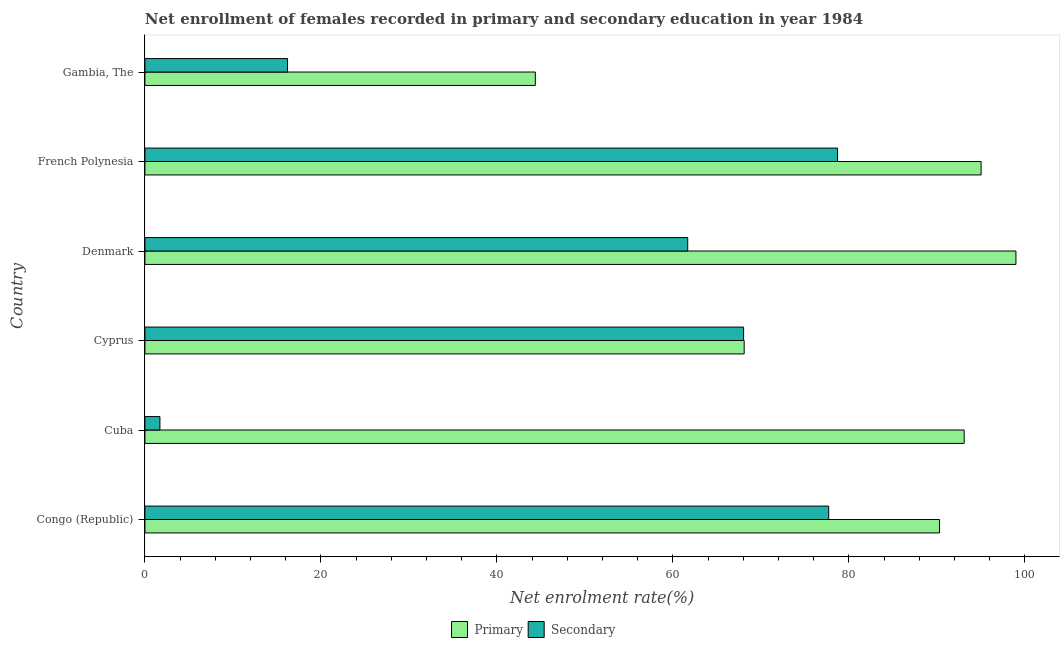How many different coloured bars are there?
Provide a succinct answer. 2. How many groups of bars are there?
Keep it short and to the point. 6. How many bars are there on the 6th tick from the bottom?
Your response must be concise. 2. What is the label of the 3rd group of bars from the top?
Keep it short and to the point. Denmark. In how many cases, is the number of bars for a given country not equal to the number of legend labels?
Provide a succinct answer. 0. What is the enrollment rate in primary education in Denmark?
Give a very brief answer. 98.98. Across all countries, what is the maximum enrollment rate in secondary education?
Offer a very short reply. 78.71. Across all countries, what is the minimum enrollment rate in secondary education?
Provide a succinct answer. 1.71. In which country was the enrollment rate in secondary education maximum?
Offer a terse response. French Polynesia. In which country was the enrollment rate in primary education minimum?
Ensure brevity in your answer.  Gambia, The. What is the total enrollment rate in secondary education in the graph?
Offer a very short reply. 304.03. What is the difference between the enrollment rate in secondary education in Congo (Republic) and that in French Polynesia?
Give a very brief answer. -1.01. What is the difference between the enrollment rate in primary education in French Polynesia and the enrollment rate in secondary education in Denmark?
Give a very brief answer. 33.34. What is the average enrollment rate in primary education per country?
Make the answer very short. 81.64. What is the difference between the enrollment rate in primary education and enrollment rate in secondary education in Cuba?
Offer a terse response. 91.39. What is the ratio of the enrollment rate in primary education in Cyprus to that in Gambia, The?
Provide a short and direct response. 1.53. Is the difference between the enrollment rate in secondary education in Cuba and Cyprus greater than the difference between the enrollment rate in primary education in Cuba and Cyprus?
Make the answer very short. No. What is the difference between the highest and the second highest enrollment rate in secondary education?
Your response must be concise. 1.01. What is the difference between the highest and the lowest enrollment rate in primary education?
Your answer should be compact. 54.62. What does the 2nd bar from the top in Cuba represents?
Your answer should be compact. Primary. What does the 2nd bar from the bottom in Cuba represents?
Keep it short and to the point. Secondary. Are all the bars in the graph horizontal?
Provide a short and direct response. Yes. How many countries are there in the graph?
Keep it short and to the point. 6. Are the values on the major ticks of X-axis written in scientific E-notation?
Offer a very short reply. No. Does the graph contain any zero values?
Your answer should be very brief. No. Does the graph contain grids?
Keep it short and to the point. No. What is the title of the graph?
Your answer should be compact. Net enrollment of females recorded in primary and secondary education in year 1984. Does "Under-5(male)" appear as one of the legend labels in the graph?
Keep it short and to the point. No. What is the label or title of the X-axis?
Provide a succinct answer. Net enrolment rate(%). What is the label or title of the Y-axis?
Your response must be concise. Country. What is the Net enrolment rate(%) of Primary in Congo (Republic)?
Offer a very short reply. 90.3. What is the Net enrolment rate(%) of Secondary in Congo (Republic)?
Offer a terse response. 77.7. What is the Net enrolment rate(%) of Primary in Cuba?
Your response must be concise. 93.1. What is the Net enrolment rate(%) in Secondary in Cuba?
Give a very brief answer. 1.71. What is the Net enrolment rate(%) in Primary in Cyprus?
Your response must be concise. 68.1. What is the Net enrolment rate(%) in Secondary in Cyprus?
Your answer should be compact. 68.03. What is the Net enrolment rate(%) in Primary in Denmark?
Give a very brief answer. 98.98. What is the Net enrolment rate(%) in Secondary in Denmark?
Keep it short and to the point. 61.68. What is the Net enrolment rate(%) of Primary in French Polynesia?
Your answer should be very brief. 95.02. What is the Net enrolment rate(%) of Secondary in French Polynesia?
Provide a succinct answer. 78.71. What is the Net enrolment rate(%) of Primary in Gambia, The?
Ensure brevity in your answer.  44.36. What is the Net enrolment rate(%) of Secondary in Gambia, The?
Provide a short and direct response. 16.21. Across all countries, what is the maximum Net enrolment rate(%) of Primary?
Your answer should be compact. 98.98. Across all countries, what is the maximum Net enrolment rate(%) of Secondary?
Make the answer very short. 78.71. Across all countries, what is the minimum Net enrolment rate(%) in Primary?
Your answer should be compact. 44.36. Across all countries, what is the minimum Net enrolment rate(%) in Secondary?
Make the answer very short. 1.71. What is the total Net enrolment rate(%) in Primary in the graph?
Keep it short and to the point. 489.85. What is the total Net enrolment rate(%) of Secondary in the graph?
Offer a terse response. 304.03. What is the difference between the Net enrolment rate(%) in Primary in Congo (Republic) and that in Cuba?
Offer a very short reply. -2.8. What is the difference between the Net enrolment rate(%) of Secondary in Congo (Republic) and that in Cuba?
Your answer should be compact. 76. What is the difference between the Net enrolment rate(%) of Primary in Congo (Republic) and that in Cyprus?
Offer a very short reply. 22.2. What is the difference between the Net enrolment rate(%) in Secondary in Congo (Republic) and that in Cyprus?
Give a very brief answer. 9.67. What is the difference between the Net enrolment rate(%) in Primary in Congo (Republic) and that in Denmark?
Offer a very short reply. -8.68. What is the difference between the Net enrolment rate(%) of Secondary in Congo (Republic) and that in Denmark?
Your response must be concise. 16.02. What is the difference between the Net enrolment rate(%) in Primary in Congo (Republic) and that in French Polynesia?
Your answer should be very brief. -4.72. What is the difference between the Net enrolment rate(%) in Secondary in Congo (Republic) and that in French Polynesia?
Your answer should be compact. -1.01. What is the difference between the Net enrolment rate(%) of Primary in Congo (Republic) and that in Gambia, The?
Offer a very short reply. 45.94. What is the difference between the Net enrolment rate(%) in Secondary in Congo (Republic) and that in Gambia, The?
Keep it short and to the point. 61.49. What is the difference between the Net enrolment rate(%) of Primary in Cuba and that in Cyprus?
Your response must be concise. 25. What is the difference between the Net enrolment rate(%) in Secondary in Cuba and that in Cyprus?
Provide a succinct answer. -66.33. What is the difference between the Net enrolment rate(%) of Primary in Cuba and that in Denmark?
Provide a short and direct response. -5.88. What is the difference between the Net enrolment rate(%) in Secondary in Cuba and that in Denmark?
Keep it short and to the point. -59.97. What is the difference between the Net enrolment rate(%) of Primary in Cuba and that in French Polynesia?
Make the answer very short. -1.92. What is the difference between the Net enrolment rate(%) in Secondary in Cuba and that in French Polynesia?
Offer a very short reply. -77. What is the difference between the Net enrolment rate(%) in Primary in Cuba and that in Gambia, The?
Offer a terse response. 48.73. What is the difference between the Net enrolment rate(%) of Secondary in Cuba and that in Gambia, The?
Your answer should be very brief. -14.5. What is the difference between the Net enrolment rate(%) in Primary in Cyprus and that in Denmark?
Your answer should be compact. -30.88. What is the difference between the Net enrolment rate(%) in Secondary in Cyprus and that in Denmark?
Your answer should be very brief. 6.35. What is the difference between the Net enrolment rate(%) in Primary in Cyprus and that in French Polynesia?
Offer a terse response. -26.92. What is the difference between the Net enrolment rate(%) in Secondary in Cyprus and that in French Polynesia?
Make the answer very short. -10.68. What is the difference between the Net enrolment rate(%) in Primary in Cyprus and that in Gambia, The?
Offer a terse response. 23.74. What is the difference between the Net enrolment rate(%) of Secondary in Cyprus and that in Gambia, The?
Offer a very short reply. 51.83. What is the difference between the Net enrolment rate(%) of Primary in Denmark and that in French Polynesia?
Give a very brief answer. 3.96. What is the difference between the Net enrolment rate(%) in Secondary in Denmark and that in French Polynesia?
Ensure brevity in your answer.  -17.03. What is the difference between the Net enrolment rate(%) in Primary in Denmark and that in Gambia, The?
Your response must be concise. 54.62. What is the difference between the Net enrolment rate(%) of Secondary in Denmark and that in Gambia, The?
Offer a very short reply. 45.47. What is the difference between the Net enrolment rate(%) of Primary in French Polynesia and that in Gambia, The?
Make the answer very short. 50.66. What is the difference between the Net enrolment rate(%) in Secondary in French Polynesia and that in Gambia, The?
Ensure brevity in your answer.  62.5. What is the difference between the Net enrolment rate(%) of Primary in Congo (Republic) and the Net enrolment rate(%) of Secondary in Cuba?
Keep it short and to the point. 88.59. What is the difference between the Net enrolment rate(%) in Primary in Congo (Republic) and the Net enrolment rate(%) in Secondary in Cyprus?
Make the answer very short. 22.27. What is the difference between the Net enrolment rate(%) in Primary in Congo (Republic) and the Net enrolment rate(%) in Secondary in Denmark?
Your answer should be very brief. 28.62. What is the difference between the Net enrolment rate(%) of Primary in Congo (Republic) and the Net enrolment rate(%) of Secondary in French Polynesia?
Your answer should be very brief. 11.59. What is the difference between the Net enrolment rate(%) in Primary in Congo (Republic) and the Net enrolment rate(%) in Secondary in Gambia, The?
Provide a short and direct response. 74.09. What is the difference between the Net enrolment rate(%) of Primary in Cuba and the Net enrolment rate(%) of Secondary in Cyprus?
Ensure brevity in your answer.  25.06. What is the difference between the Net enrolment rate(%) in Primary in Cuba and the Net enrolment rate(%) in Secondary in Denmark?
Provide a succinct answer. 31.42. What is the difference between the Net enrolment rate(%) of Primary in Cuba and the Net enrolment rate(%) of Secondary in French Polynesia?
Offer a very short reply. 14.39. What is the difference between the Net enrolment rate(%) of Primary in Cuba and the Net enrolment rate(%) of Secondary in Gambia, The?
Offer a very short reply. 76.89. What is the difference between the Net enrolment rate(%) of Primary in Cyprus and the Net enrolment rate(%) of Secondary in Denmark?
Offer a terse response. 6.42. What is the difference between the Net enrolment rate(%) in Primary in Cyprus and the Net enrolment rate(%) in Secondary in French Polynesia?
Offer a very short reply. -10.61. What is the difference between the Net enrolment rate(%) of Primary in Cyprus and the Net enrolment rate(%) of Secondary in Gambia, The?
Provide a short and direct response. 51.89. What is the difference between the Net enrolment rate(%) in Primary in Denmark and the Net enrolment rate(%) in Secondary in French Polynesia?
Offer a very short reply. 20.27. What is the difference between the Net enrolment rate(%) in Primary in Denmark and the Net enrolment rate(%) in Secondary in Gambia, The?
Provide a succinct answer. 82.77. What is the difference between the Net enrolment rate(%) of Primary in French Polynesia and the Net enrolment rate(%) of Secondary in Gambia, The?
Give a very brief answer. 78.81. What is the average Net enrolment rate(%) in Primary per country?
Offer a very short reply. 81.64. What is the average Net enrolment rate(%) in Secondary per country?
Provide a succinct answer. 50.67. What is the difference between the Net enrolment rate(%) in Primary and Net enrolment rate(%) in Secondary in Congo (Republic)?
Offer a very short reply. 12.6. What is the difference between the Net enrolment rate(%) of Primary and Net enrolment rate(%) of Secondary in Cuba?
Give a very brief answer. 91.39. What is the difference between the Net enrolment rate(%) in Primary and Net enrolment rate(%) in Secondary in Cyprus?
Ensure brevity in your answer.  0.06. What is the difference between the Net enrolment rate(%) in Primary and Net enrolment rate(%) in Secondary in Denmark?
Your response must be concise. 37.3. What is the difference between the Net enrolment rate(%) of Primary and Net enrolment rate(%) of Secondary in French Polynesia?
Give a very brief answer. 16.31. What is the difference between the Net enrolment rate(%) in Primary and Net enrolment rate(%) in Secondary in Gambia, The?
Keep it short and to the point. 28.15. What is the ratio of the Net enrolment rate(%) in Primary in Congo (Republic) to that in Cuba?
Your answer should be compact. 0.97. What is the ratio of the Net enrolment rate(%) in Secondary in Congo (Republic) to that in Cuba?
Your answer should be very brief. 45.57. What is the ratio of the Net enrolment rate(%) of Primary in Congo (Republic) to that in Cyprus?
Offer a very short reply. 1.33. What is the ratio of the Net enrolment rate(%) in Secondary in Congo (Republic) to that in Cyprus?
Provide a short and direct response. 1.14. What is the ratio of the Net enrolment rate(%) of Primary in Congo (Republic) to that in Denmark?
Ensure brevity in your answer.  0.91. What is the ratio of the Net enrolment rate(%) in Secondary in Congo (Republic) to that in Denmark?
Provide a short and direct response. 1.26. What is the ratio of the Net enrolment rate(%) in Primary in Congo (Republic) to that in French Polynesia?
Provide a succinct answer. 0.95. What is the ratio of the Net enrolment rate(%) of Secondary in Congo (Republic) to that in French Polynesia?
Your response must be concise. 0.99. What is the ratio of the Net enrolment rate(%) in Primary in Congo (Republic) to that in Gambia, The?
Offer a very short reply. 2.04. What is the ratio of the Net enrolment rate(%) of Secondary in Congo (Republic) to that in Gambia, The?
Make the answer very short. 4.79. What is the ratio of the Net enrolment rate(%) in Primary in Cuba to that in Cyprus?
Ensure brevity in your answer.  1.37. What is the ratio of the Net enrolment rate(%) of Secondary in Cuba to that in Cyprus?
Your answer should be very brief. 0.03. What is the ratio of the Net enrolment rate(%) in Primary in Cuba to that in Denmark?
Offer a very short reply. 0.94. What is the ratio of the Net enrolment rate(%) of Secondary in Cuba to that in Denmark?
Keep it short and to the point. 0.03. What is the ratio of the Net enrolment rate(%) of Primary in Cuba to that in French Polynesia?
Your answer should be compact. 0.98. What is the ratio of the Net enrolment rate(%) of Secondary in Cuba to that in French Polynesia?
Make the answer very short. 0.02. What is the ratio of the Net enrolment rate(%) in Primary in Cuba to that in Gambia, The?
Keep it short and to the point. 2.1. What is the ratio of the Net enrolment rate(%) of Secondary in Cuba to that in Gambia, The?
Your response must be concise. 0.11. What is the ratio of the Net enrolment rate(%) of Primary in Cyprus to that in Denmark?
Offer a very short reply. 0.69. What is the ratio of the Net enrolment rate(%) in Secondary in Cyprus to that in Denmark?
Provide a short and direct response. 1.1. What is the ratio of the Net enrolment rate(%) of Primary in Cyprus to that in French Polynesia?
Ensure brevity in your answer.  0.72. What is the ratio of the Net enrolment rate(%) of Secondary in Cyprus to that in French Polynesia?
Provide a succinct answer. 0.86. What is the ratio of the Net enrolment rate(%) in Primary in Cyprus to that in Gambia, The?
Provide a succinct answer. 1.53. What is the ratio of the Net enrolment rate(%) in Secondary in Cyprus to that in Gambia, The?
Keep it short and to the point. 4.2. What is the ratio of the Net enrolment rate(%) of Primary in Denmark to that in French Polynesia?
Ensure brevity in your answer.  1.04. What is the ratio of the Net enrolment rate(%) of Secondary in Denmark to that in French Polynesia?
Your answer should be very brief. 0.78. What is the ratio of the Net enrolment rate(%) of Primary in Denmark to that in Gambia, The?
Provide a succinct answer. 2.23. What is the ratio of the Net enrolment rate(%) in Secondary in Denmark to that in Gambia, The?
Provide a short and direct response. 3.81. What is the ratio of the Net enrolment rate(%) in Primary in French Polynesia to that in Gambia, The?
Give a very brief answer. 2.14. What is the ratio of the Net enrolment rate(%) in Secondary in French Polynesia to that in Gambia, The?
Make the answer very short. 4.86. What is the difference between the highest and the second highest Net enrolment rate(%) in Primary?
Offer a very short reply. 3.96. What is the difference between the highest and the lowest Net enrolment rate(%) of Primary?
Give a very brief answer. 54.62. What is the difference between the highest and the lowest Net enrolment rate(%) of Secondary?
Your answer should be very brief. 77. 